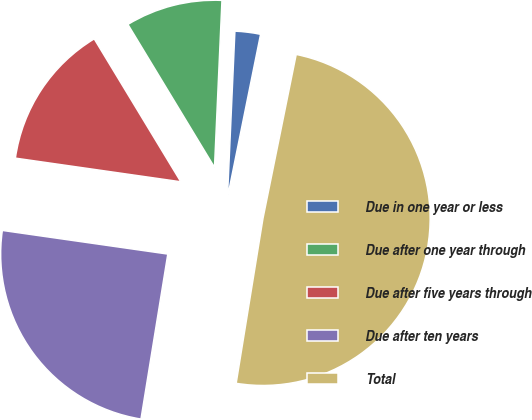Convert chart to OTSL. <chart><loc_0><loc_0><loc_500><loc_500><pie_chart><fcel>Due in one year or less<fcel>Due after one year through<fcel>Due after five years through<fcel>Due after ten years<fcel>Total<nl><fcel>2.47%<fcel>9.38%<fcel>14.07%<fcel>24.69%<fcel>49.38%<nl></chart> 